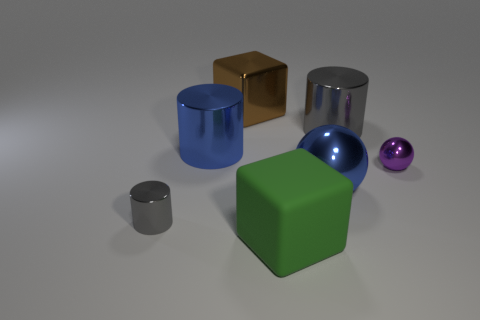What is the size of the gray cylinder behind the tiny object behind the small gray object?
Make the answer very short. Large. What is the color of the other big thing that is the same shape as the big brown shiny thing?
Keep it short and to the point. Green. Is the blue sphere the same size as the purple shiny object?
Provide a short and direct response. No. Are there an equal number of blue cylinders that are in front of the small gray metal thing and brown shiny cubes?
Your response must be concise. No. There is a shiny object that is on the right side of the big gray cylinder; are there any tiny purple shiny spheres that are left of it?
Your answer should be compact. No. There is a gray cylinder that is left of the large blue shiny thing that is left of the big block in front of the small cylinder; how big is it?
Offer a terse response. Small. What material is the cube that is in front of the gray metallic object that is right of the brown shiny cube?
Give a very brief answer. Rubber. Are there any brown things of the same shape as the green object?
Your answer should be compact. Yes. What is the shape of the small gray object?
Your answer should be compact. Cylinder. What is the gray cylinder behind the metal cylinder that is on the left side of the big blue thing behind the purple thing made of?
Your response must be concise. Metal. 